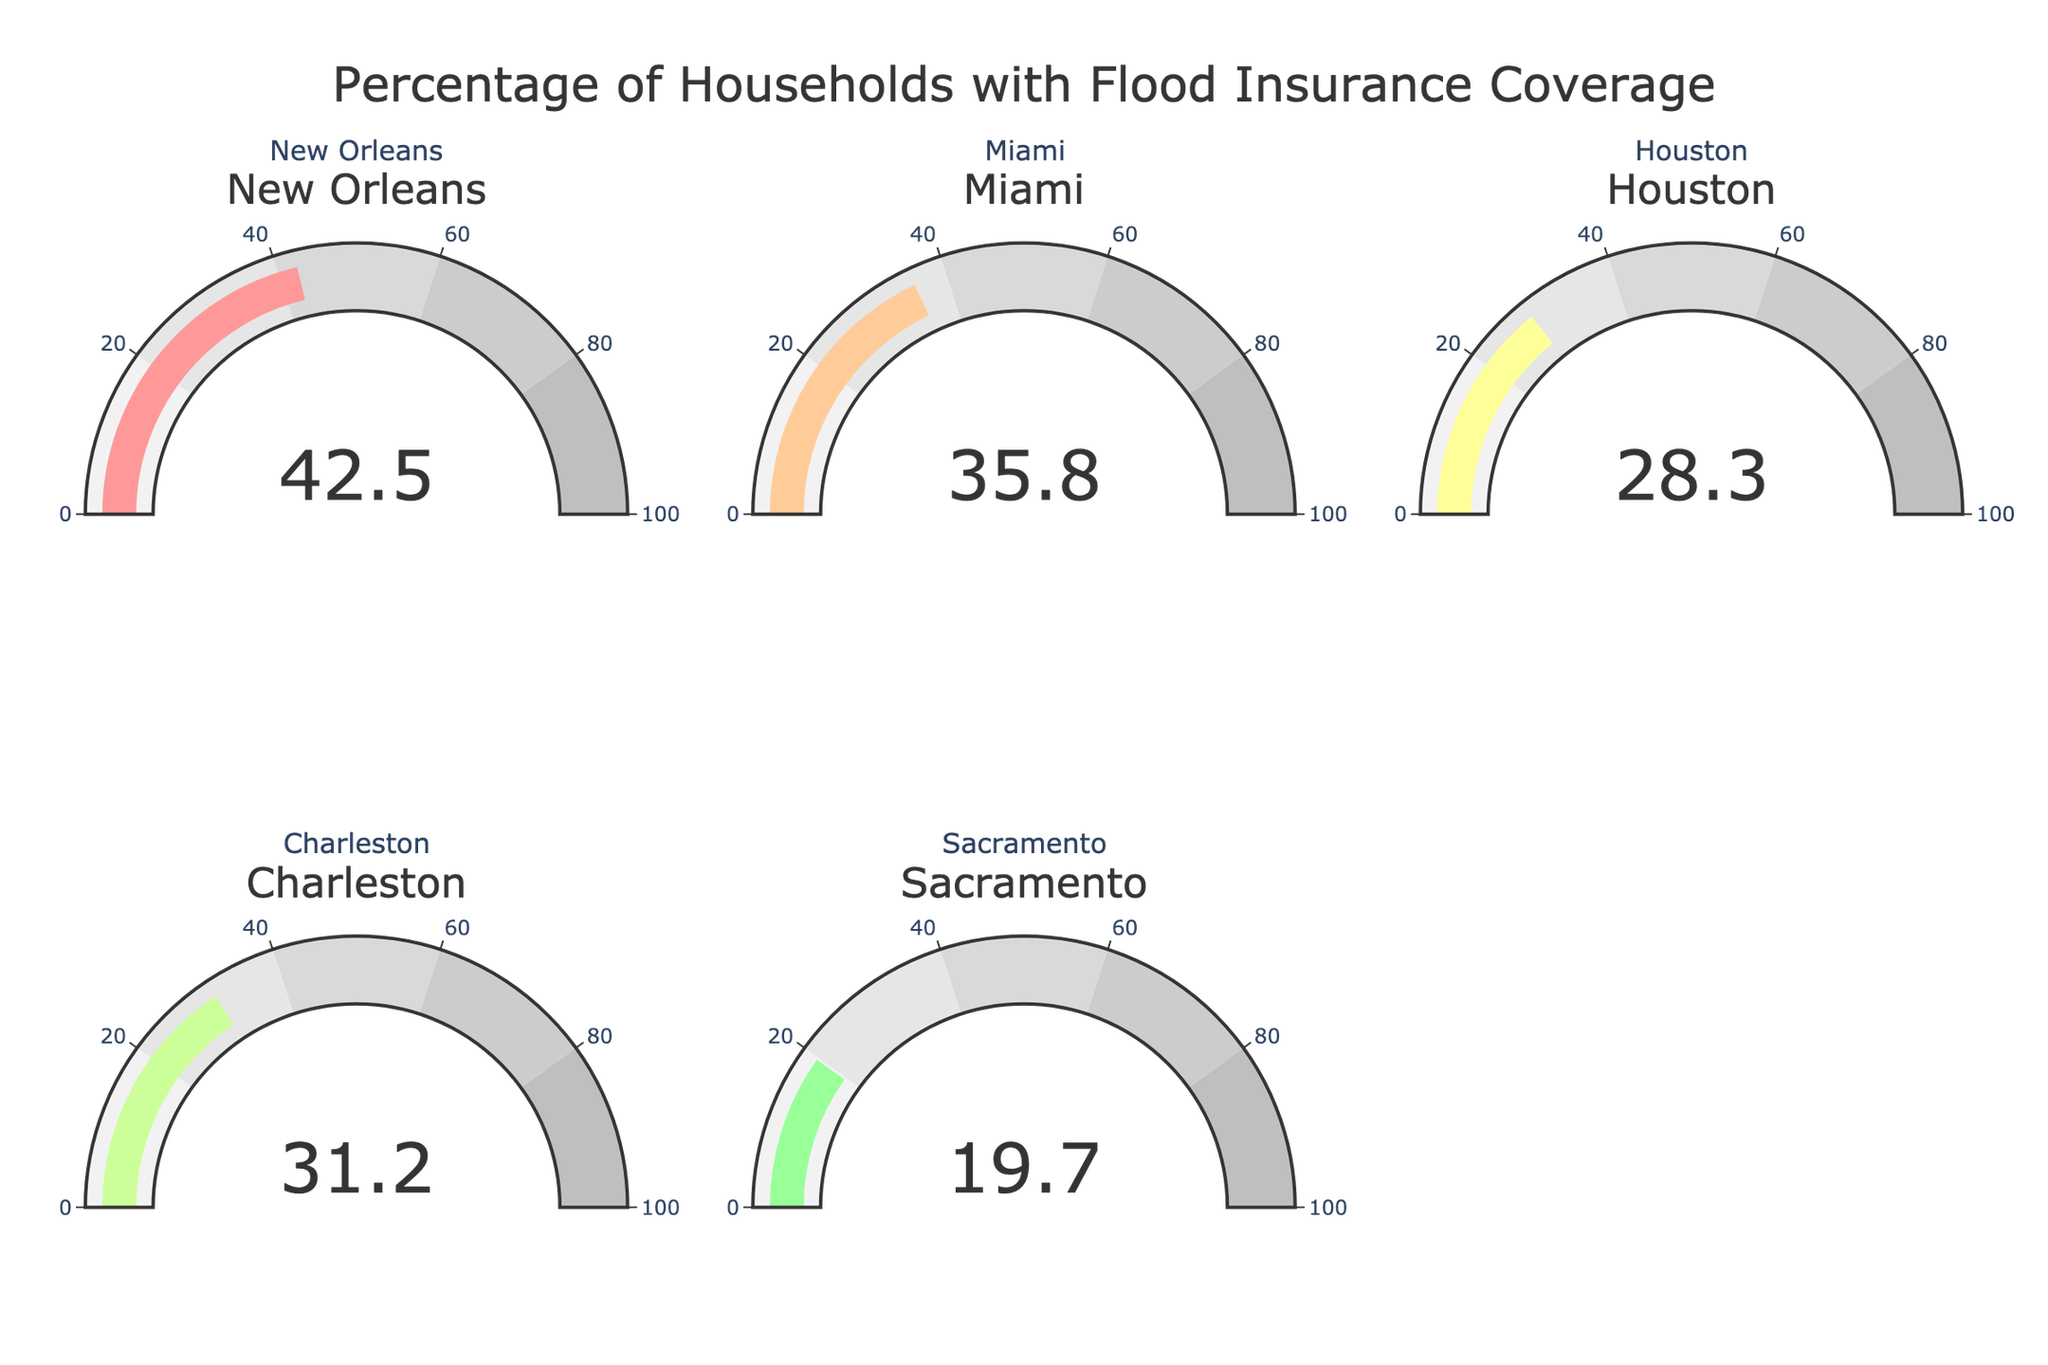How many cities are represented in the figure? Count the number of gauge charts or look for the number of different titles within the subplots. There are five cities represented.
Answer: Five Which city has the highest percentage of households with flood insurance coverage? Look at the values shown on each gauge chart and determine which is the highest. New Orleans has the highest percentage at 42.5%.
Answer: New Orleans What is the total percentage of households with flood insurance coverage for Miami and Houston combined? Add the percentages for Miami (35.8%) and Houston (28.3%). The sum is 35.8 + 28.3 = 64.1%.
Answer: 64.1% Which city has the lowest flood insurance coverage percentage, and what is it? Identify the smallest value shown on the gauge charts. Sacramento has the lowest percentage at 19.7%.
Answer: Sacramento, 19.7% Between Charleston and Sacramento, which city has a higher percentage of households with flood insurance and by how much? Compare the percentages for Charleston (31.2%) and Sacramento (19.7%), and calculate the difference: 31.2 - 19.7 = 11.5%.
Answer: Charleston, 11.5% What is the average percentage of households with flood insurance coverage across all the cities represented? Add all the percentages and divide by the number of cities: (42.5 + 35.8 + 28.3 + 31.2 + 19.7) / 5 = 31.5%.
Answer: 31.5% Are there any cities with a flood insurance coverage percentage below 30%? If so, which ones? Identify gauge charts displaying values below 30%. These cities are Houston with 28.3% and Sacramento with 19.7%.
Answer: Houston and Sacramento Which city has the closest percentage of households with flood insurance coverage to 30%? Compare each city's percentage to 30% and find which is nearest. Charleston at 31.2% is closest to 30%.
Answer: Charleston 